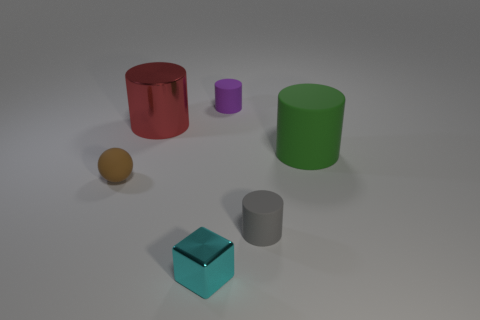Are there more metal things in front of the red cylinder than gray rubber cylinders?
Your answer should be very brief. No. The big metallic cylinder is what color?
Offer a very short reply. Red. The big object that is in front of the metal object behind the small matte cylinder that is in front of the big red metal object is what shape?
Offer a very short reply. Cylinder. There is a small thing that is both to the right of the cyan thing and in front of the red shiny thing; what material is it?
Ensure brevity in your answer.  Rubber. There is a rubber object that is on the left side of the tiny cylinder behind the brown rubber sphere; what shape is it?
Ensure brevity in your answer.  Sphere. Is there any other thing that is the same color as the tiny metallic block?
Offer a very short reply. No. There is a red metal cylinder; is its size the same as the matte thing to the left of the cyan metal object?
Ensure brevity in your answer.  No. What number of small things are yellow metal balls or red metallic cylinders?
Offer a terse response. 0. Is the number of small gray rubber things greater than the number of small red metal cylinders?
Keep it short and to the point. Yes. There is a large object to the left of the tiny matte cylinder on the right side of the small purple thing; what number of matte balls are to the left of it?
Your answer should be compact. 1. 